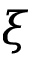<formula> <loc_0><loc_0><loc_500><loc_500>\xi</formula> 